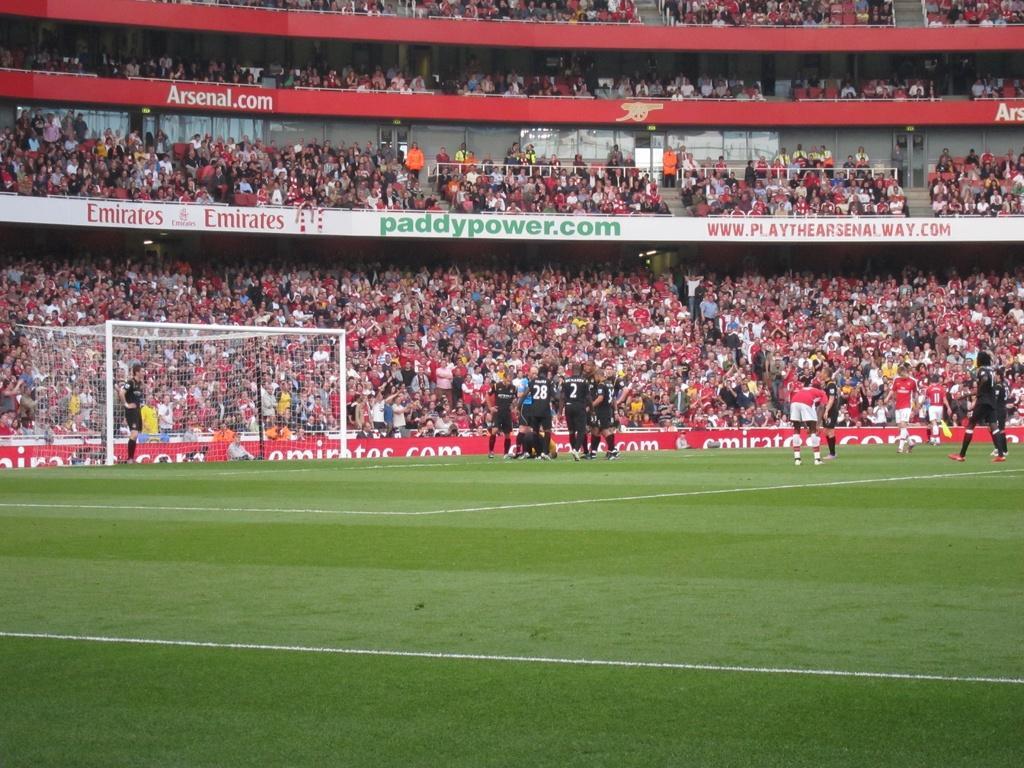Could you give a brief overview of what you see in this image? This picture is clicked outside. In the foreground we can see the green grass. In the center we can see the group of people and we can see the net, metal rods, text on the banners and in the background we can see the group of people, wall and many other objects. 